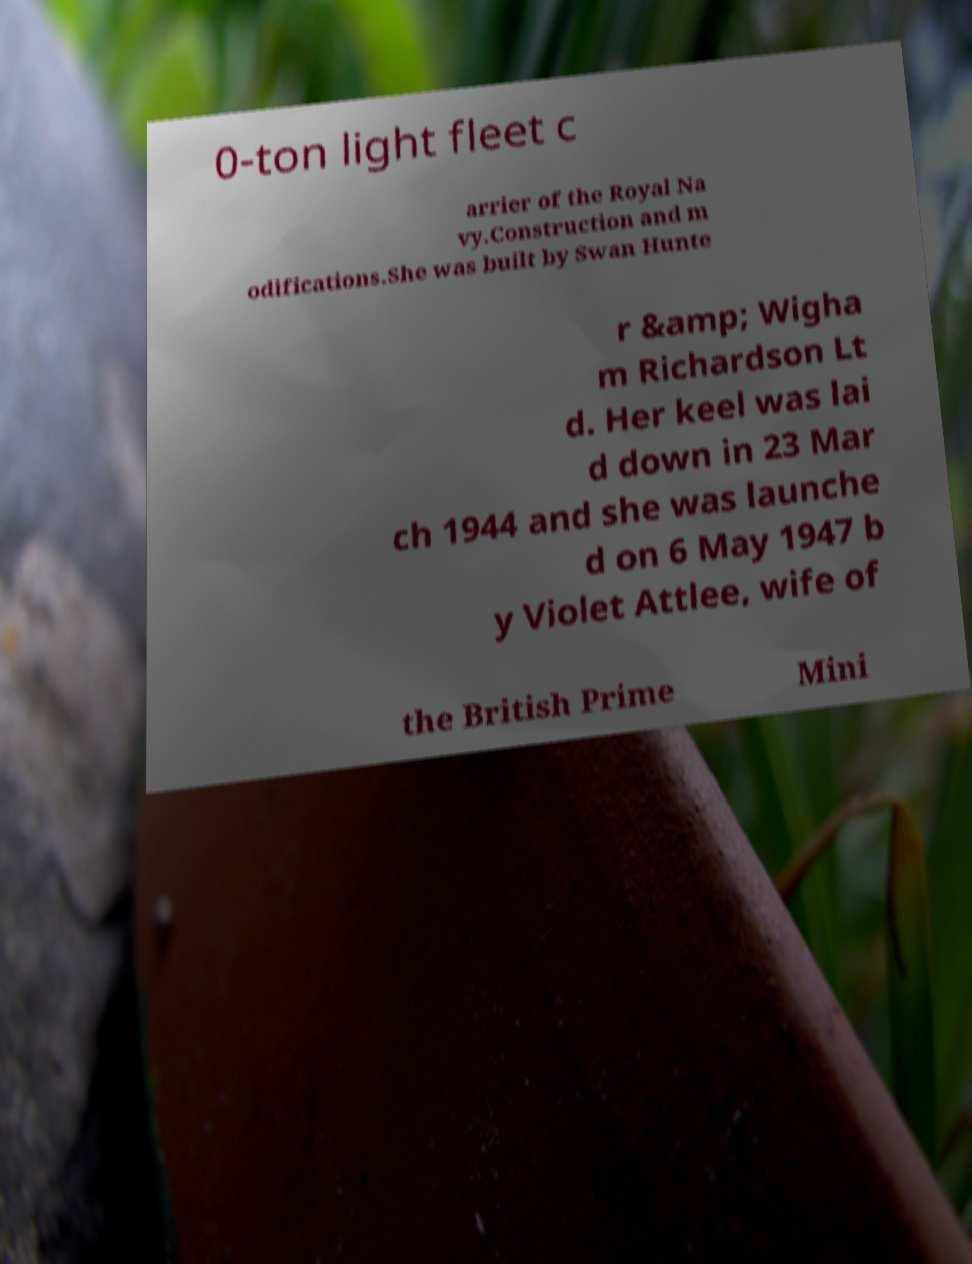For documentation purposes, I need the text within this image transcribed. Could you provide that? 0-ton light fleet c arrier of the Royal Na vy.Construction and m odifications.She was built by Swan Hunte r &amp; Wigha m Richardson Lt d. Her keel was lai d down in 23 Mar ch 1944 and she was launche d on 6 May 1947 b y Violet Attlee, wife of the British Prime Mini 